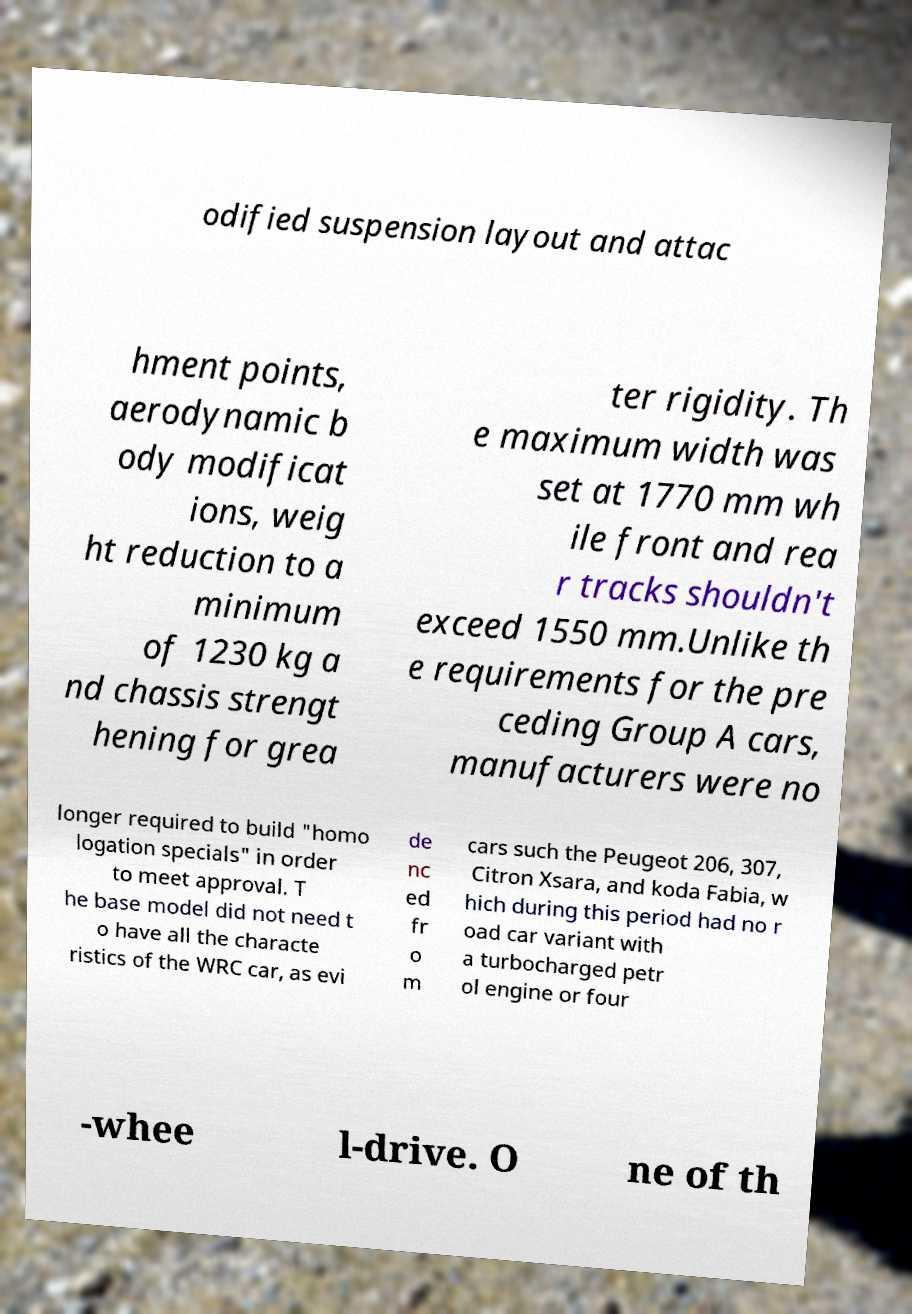I need the written content from this picture converted into text. Can you do that? odified suspension layout and attac hment points, aerodynamic b ody modificat ions, weig ht reduction to a minimum of 1230 kg a nd chassis strengt hening for grea ter rigidity. Th e maximum width was set at 1770 mm wh ile front and rea r tracks shouldn't exceed 1550 mm.Unlike th e requirements for the pre ceding Group A cars, manufacturers were no longer required to build "homo logation specials" in order to meet approval. T he base model did not need t o have all the characte ristics of the WRC car, as evi de nc ed fr o m cars such the Peugeot 206, 307, Citron Xsara, and koda Fabia, w hich during this period had no r oad car variant with a turbocharged petr ol engine or four -whee l-drive. O ne of th 